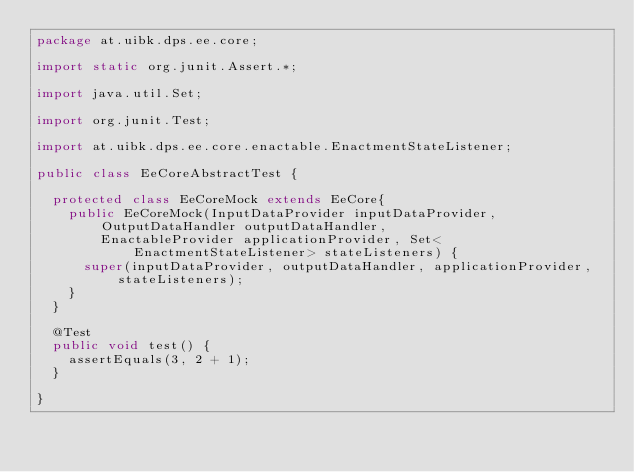<code> <loc_0><loc_0><loc_500><loc_500><_Java_>package at.uibk.dps.ee.core;

import static org.junit.Assert.*;

import java.util.Set;

import org.junit.Test;

import at.uibk.dps.ee.core.enactable.EnactmentStateListener;

public class EeCoreAbstractTest {

	protected class EeCoreMock extends EeCore{
		public EeCoreMock(InputDataProvider inputDataProvider, OutputDataHandler outputDataHandler,
				EnactableProvider applicationProvider, Set<EnactmentStateListener> stateListeners) {
			super(inputDataProvider, outputDataHandler, applicationProvider, stateListeners);
		}
	}
	
	@Test
	public void test() {
		assertEquals(3, 2 + 1);
	}

}
</code> 